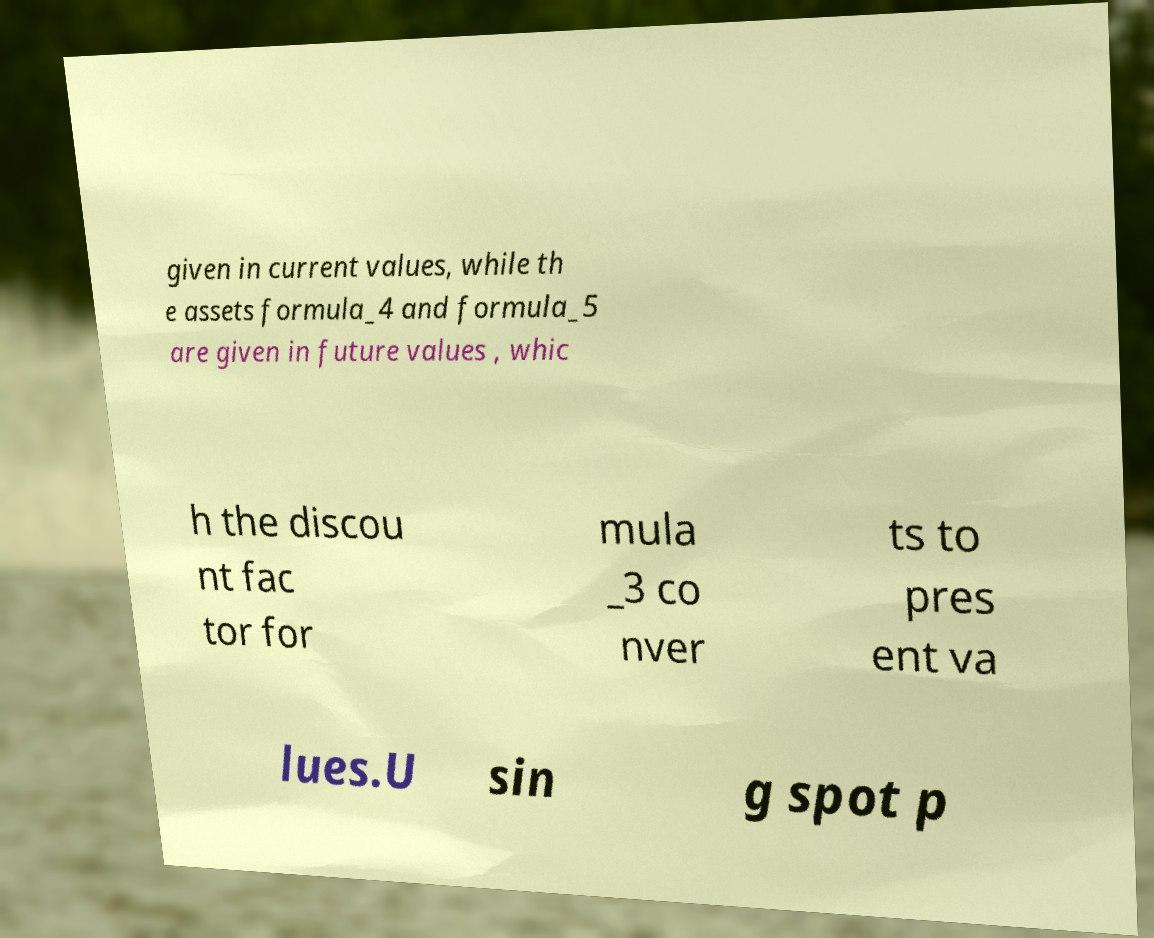Could you extract and type out the text from this image? given in current values, while th e assets formula_4 and formula_5 are given in future values , whic h the discou nt fac tor for mula _3 co nver ts to pres ent va lues.U sin g spot p 